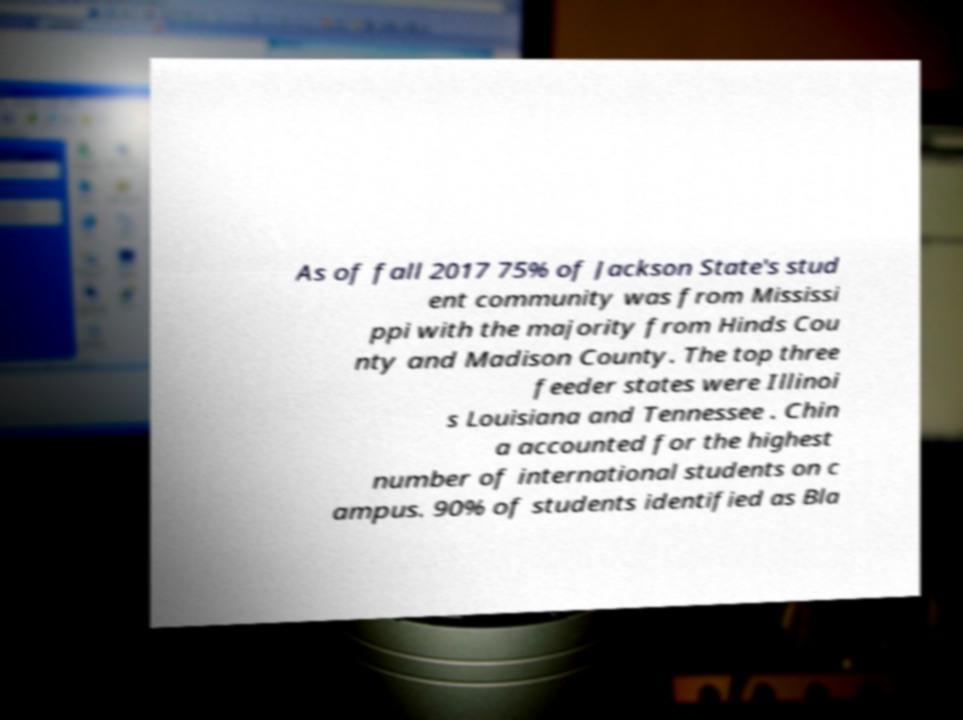Can you accurately transcribe the text from the provided image for me? As of fall 2017 75% of Jackson State's stud ent community was from Mississi ppi with the majority from Hinds Cou nty and Madison County. The top three feeder states were Illinoi s Louisiana and Tennessee . Chin a accounted for the highest number of international students on c ampus. 90% of students identified as Bla 